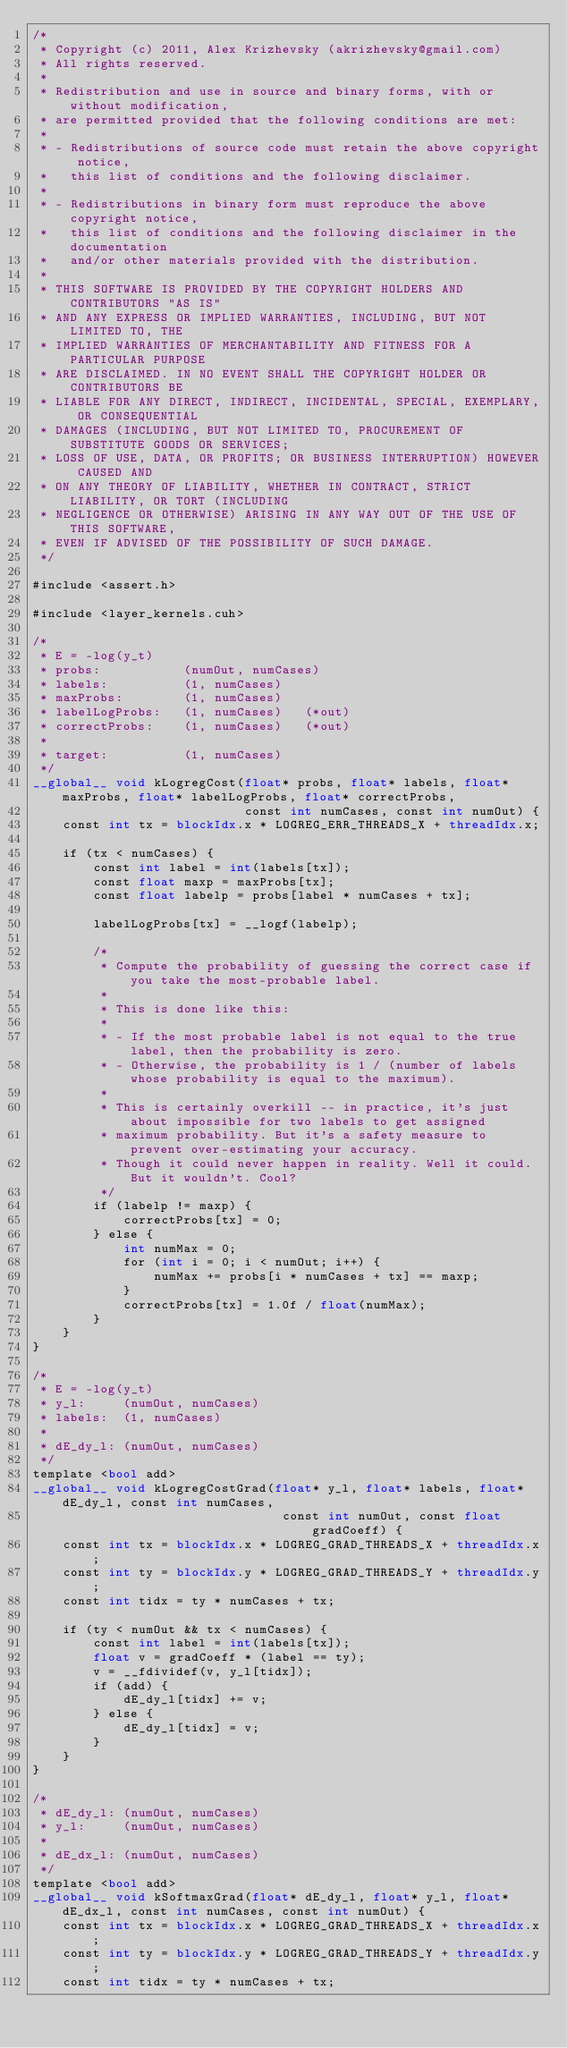Convert code to text. <code><loc_0><loc_0><loc_500><loc_500><_Cuda_>/* 
 * Copyright (c) 2011, Alex Krizhevsky (akrizhevsky@gmail.com)
 * All rights reserved.
 *
 * Redistribution and use in source and binary forms, with or without modification,
 * are permitted provided that the following conditions are met:
 *
 * - Redistributions of source code must retain the above copyright notice,
 *   this list of conditions and the following disclaimer.
 * 
 * - Redistributions in binary form must reproduce the above copyright notice,
 *   this list of conditions and the following disclaimer in the documentation
 *   and/or other materials provided with the distribution.
 *
 * THIS SOFTWARE IS PROVIDED BY THE COPYRIGHT HOLDERS AND CONTRIBUTORS "AS IS"
 * AND ANY EXPRESS OR IMPLIED WARRANTIES, INCLUDING, BUT NOT LIMITED TO, THE
 * IMPLIED WARRANTIES OF MERCHANTABILITY AND FITNESS FOR A PARTICULAR PURPOSE
 * ARE DISCLAIMED. IN NO EVENT SHALL THE COPYRIGHT HOLDER OR CONTRIBUTORS BE
 * LIABLE FOR ANY DIRECT, INDIRECT, INCIDENTAL, SPECIAL, EXEMPLARY, OR CONSEQUENTIAL
 * DAMAGES (INCLUDING, BUT NOT LIMITED TO, PROCUREMENT OF SUBSTITUTE GOODS OR SERVICES;
 * LOSS OF USE, DATA, OR PROFITS; OR BUSINESS INTERRUPTION) HOWEVER CAUSED AND
 * ON ANY THEORY OF LIABILITY, WHETHER IN CONTRACT, STRICT LIABILITY, OR TORT (INCLUDING
 * NEGLIGENCE OR OTHERWISE) ARISING IN ANY WAY OUT OF THE USE OF THIS SOFTWARE,
 * EVEN IF ADVISED OF THE POSSIBILITY OF SUCH DAMAGE.
 */

#include <assert.h>

#include <layer_kernels.cuh>

/*
 * E = -log(y_t)
 * probs:           (numOut, numCases)
 * labels:          (1, numCases)
 * maxProbs:        (1, numCases)
 * labelLogProbs:   (1, numCases)   (*out)
 * correctProbs:    (1, numCases)   (*out)
 * 
 * target:          (1, numCases)
 */
__global__ void kLogregCost(float* probs, float* labels, float* maxProbs, float* labelLogProbs, float* correctProbs,
                            const int numCases, const int numOut) {
    const int tx = blockIdx.x * LOGREG_ERR_THREADS_X + threadIdx.x;

    if (tx < numCases) {
        const int label = int(labels[tx]);
        const float maxp = maxProbs[tx];
        const float labelp = probs[label * numCases + tx];
        
        labelLogProbs[tx] = __logf(labelp);
        
        /*
         * Compute the probability of guessing the correct case if you take the most-probable label.
         * 
         * This is done like this:
         * 
         * - If the most probable label is not equal to the true label, then the probability is zero.
         * - Otherwise, the probability is 1 / (number of labels whose probability is equal to the maximum).
         * 
         * This is certainly overkill -- in practice, it's just about impossible for two labels to get assigned
         * maximum probability. But it's a safety measure to prevent over-estimating your accuracy.
         * Though it could never happen in reality. Well it could. But it wouldn't. Cool?
         */
        if (labelp != maxp) {
            correctProbs[tx] = 0;
        } else {
            int numMax = 0;
            for (int i = 0; i < numOut; i++) {
                numMax += probs[i * numCases + tx] == maxp;
            }
            correctProbs[tx] = 1.0f / float(numMax);
        }
    }
}

/*
 * E = -log(y_t)
 * y_l:     (numOut, numCases)
 * labels:  (1, numCases)
 * 
 * dE_dy_l: (numOut, numCases)
 */
template <bool add>
__global__ void kLogregCostGrad(float* y_l, float* labels, float* dE_dy_l, const int numCases,
                                 const int numOut, const float gradCoeff) {
    const int tx = blockIdx.x * LOGREG_GRAD_THREADS_X + threadIdx.x;
    const int ty = blockIdx.y * LOGREG_GRAD_THREADS_Y + threadIdx.y;
    const int tidx = ty * numCases + tx;
    
    if (ty < numOut && tx < numCases) {
        const int label = int(labels[tx]);
        float v = gradCoeff * (label == ty);
        v = __fdividef(v, y_l[tidx]);
        if (add) {
            dE_dy_l[tidx] += v;
        } else {
            dE_dy_l[tidx] = v;
        }
    }
}

/*
 * dE_dy_l: (numOut, numCases)
 * y_l:     (numOut, numCases)
 * 
 * dE_dx_l: (numOut, numCases)
 */
template <bool add>
__global__ void kSoftmaxGrad(float* dE_dy_l, float* y_l, float* dE_dx_l, const int numCases, const int numOut) {
    const int tx = blockIdx.x * LOGREG_GRAD_THREADS_X + threadIdx.x;
    const int ty = blockIdx.y * LOGREG_GRAD_THREADS_Y + threadIdx.y;
    const int tidx = ty * numCases + tx;
    </code> 